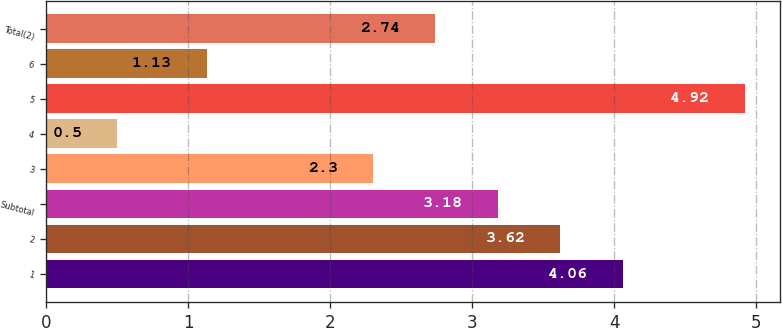Convert chart. <chart><loc_0><loc_0><loc_500><loc_500><bar_chart><fcel>1<fcel>2<fcel>Subtotal<fcel>3<fcel>4<fcel>5<fcel>6<fcel>Total(2)<nl><fcel>4.06<fcel>3.62<fcel>3.18<fcel>2.3<fcel>0.5<fcel>4.92<fcel>1.13<fcel>2.74<nl></chart> 